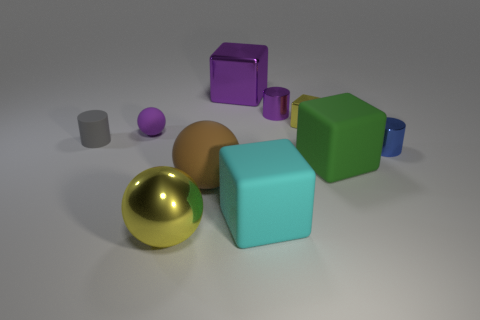What color is the metallic block that is the same size as the gray thing?
Provide a short and direct response. Yellow. How many rubber objects are the same shape as the tiny yellow metal object?
Provide a succinct answer. 2. What number of spheres are either small cyan things or large purple things?
Your answer should be compact. 0. Do the yellow object behind the large brown thing and the large thing that is behind the rubber cylinder have the same shape?
Provide a short and direct response. Yes. What is the material of the big yellow thing?
Your answer should be compact. Metal. There is a big object that is the same color as the small matte ball; what shape is it?
Ensure brevity in your answer.  Cube. How many yellow cubes have the same size as the blue metal object?
Provide a succinct answer. 1. How many objects are either blocks in front of the big brown ball or tiny things in front of the tiny yellow object?
Offer a terse response. 4. Is the material of the yellow thing behind the brown rubber thing the same as the yellow object that is in front of the brown matte object?
Offer a very short reply. Yes. The purple thing that is in front of the purple metal object in front of the purple cube is what shape?
Your answer should be compact. Sphere. 